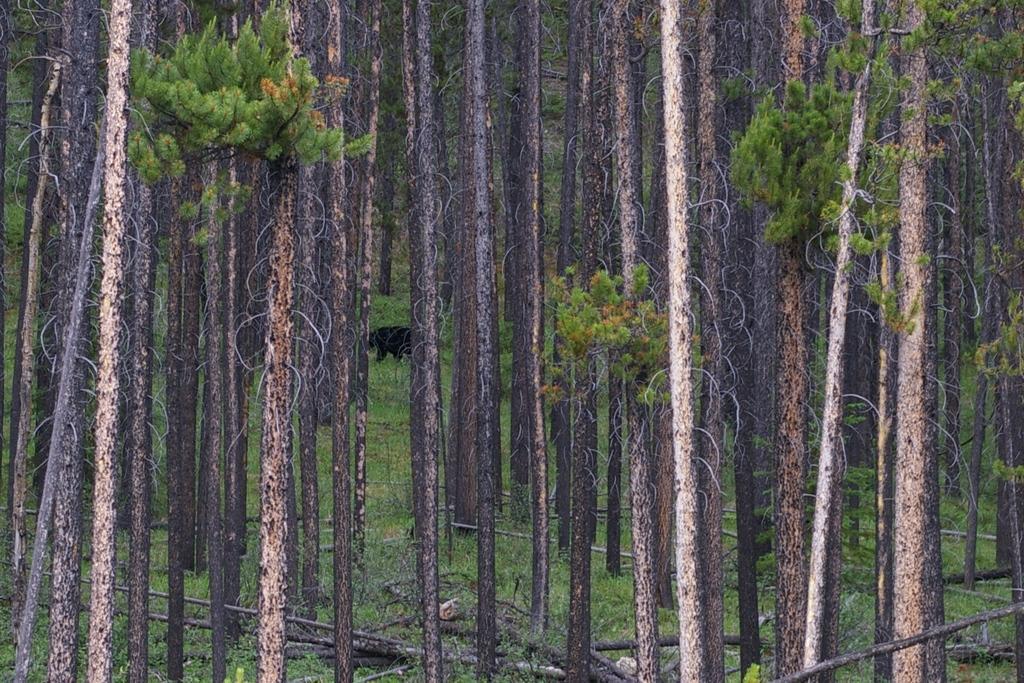How would you summarize this image in a sentence or two? In this image there are trees. There is an animal. At the bottom of the image there are wooden logs and grass on the surface. 